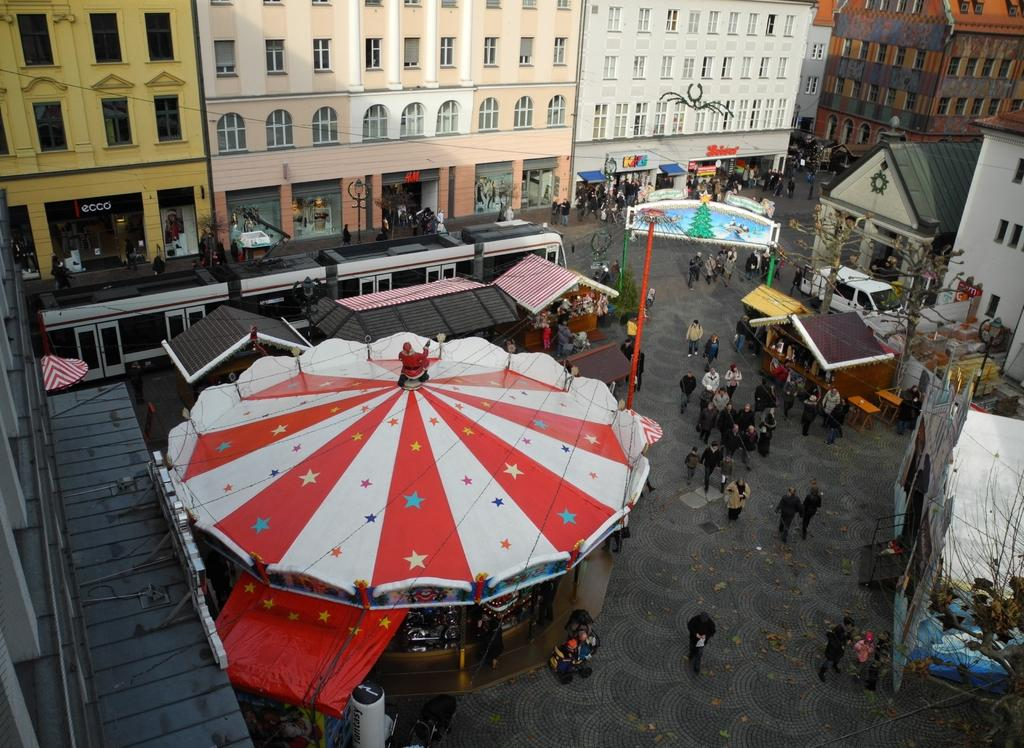What are the people in the image doing? The people in the image are walking on the ground. What can be seen in the background of the image? There are buildings and trees visible in the image. What are the poles used for in the image? The purpose of the poles is not specified in the image, but they may be used for various purposes such as streetlights or signage. What types of vehicles are present in the image? Vehicles are present in the image, but their specific types are not mentioned. Can you describe any other objects in the image? There are other objects in the image, but their specific details are not provided. Where is the jar located in the image? There is no jar present in the image. What type of rod can be seen connecting the buildings in the image? There is no rod connecting the buildings in the image. What railway is visible in the image? There is no railway present in the image. 